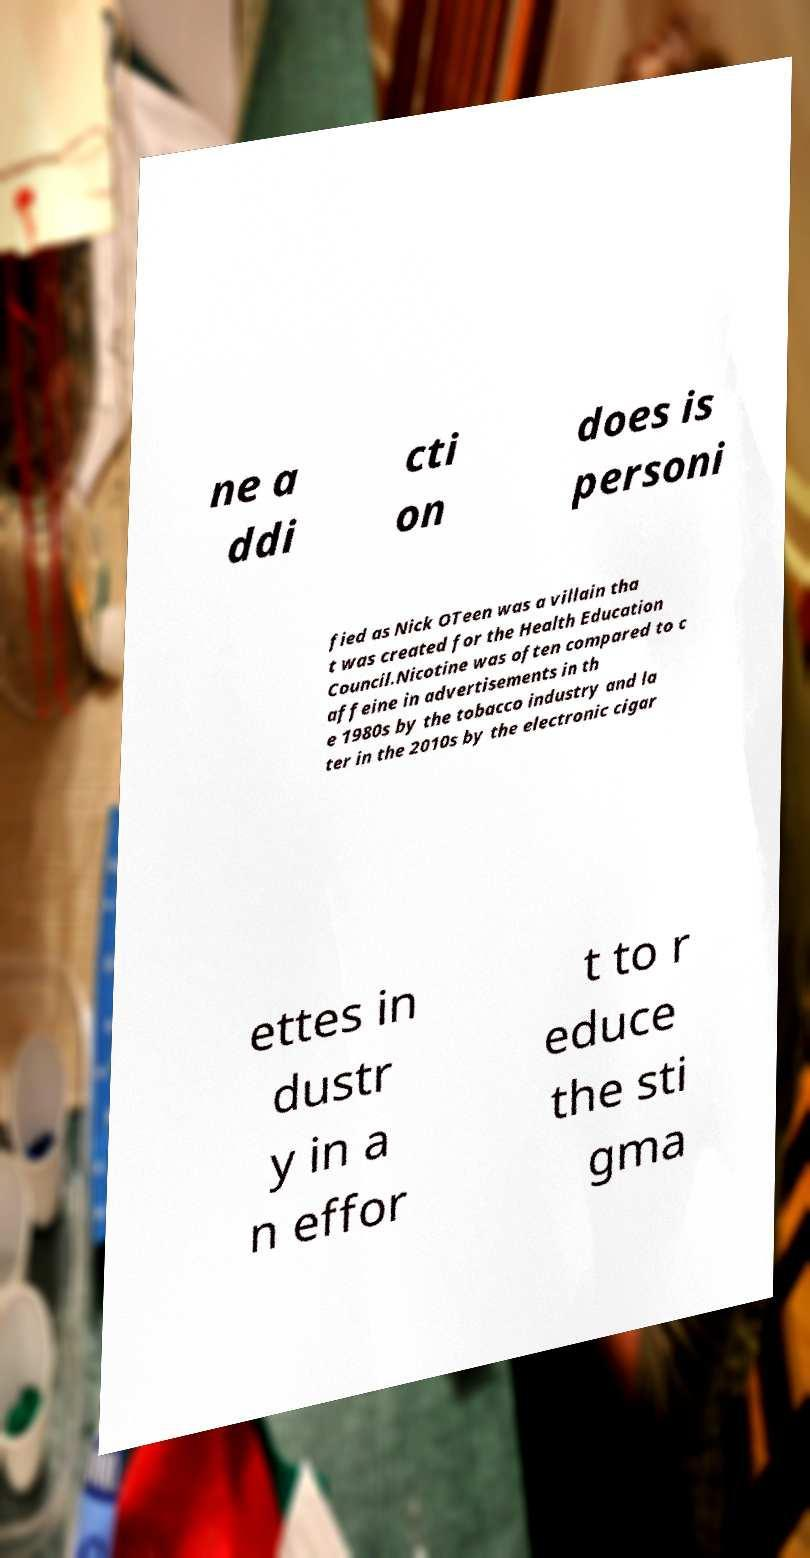Can you accurately transcribe the text from the provided image for me? ne a ddi cti on does is personi fied as Nick OTeen was a villain tha t was created for the Health Education Council.Nicotine was often compared to c affeine in advertisements in th e 1980s by the tobacco industry and la ter in the 2010s by the electronic cigar ettes in dustr y in a n effor t to r educe the sti gma 